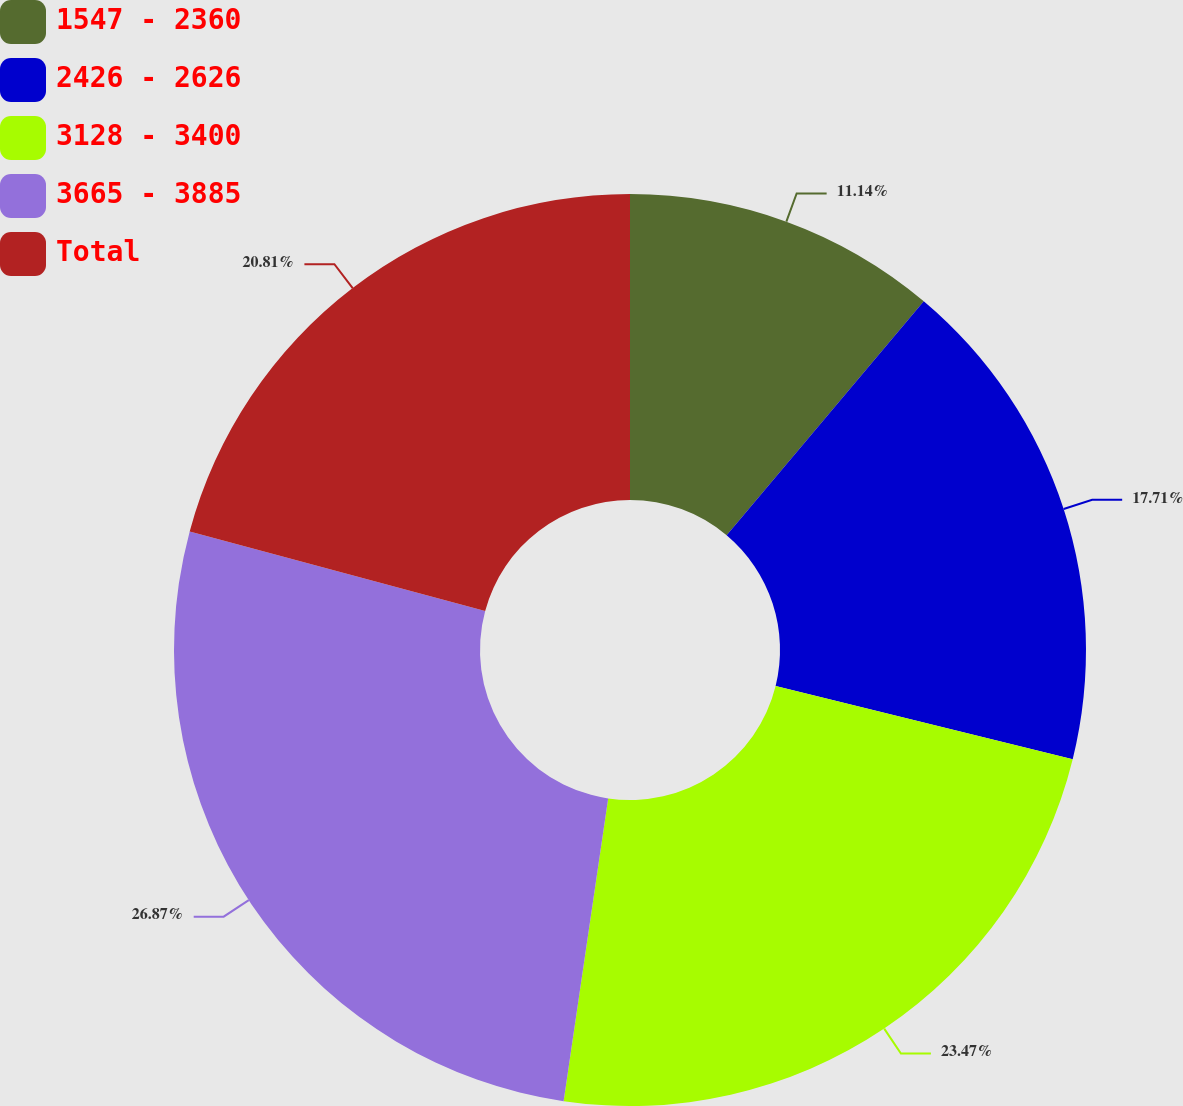<chart> <loc_0><loc_0><loc_500><loc_500><pie_chart><fcel>1547 - 2360<fcel>2426 - 2626<fcel>3128 - 3400<fcel>3665 - 3885<fcel>Total<nl><fcel>11.14%<fcel>17.71%<fcel>23.47%<fcel>26.86%<fcel>20.81%<nl></chart> 